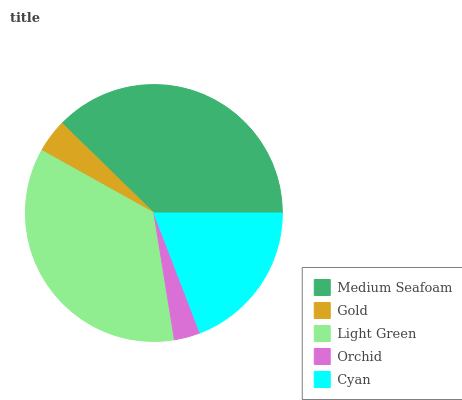Is Orchid the minimum?
Answer yes or no. Yes. Is Medium Seafoam the maximum?
Answer yes or no. Yes. Is Gold the minimum?
Answer yes or no. No. Is Gold the maximum?
Answer yes or no. No. Is Medium Seafoam greater than Gold?
Answer yes or no. Yes. Is Gold less than Medium Seafoam?
Answer yes or no. Yes. Is Gold greater than Medium Seafoam?
Answer yes or no. No. Is Medium Seafoam less than Gold?
Answer yes or no. No. Is Cyan the high median?
Answer yes or no. Yes. Is Cyan the low median?
Answer yes or no. Yes. Is Medium Seafoam the high median?
Answer yes or no. No. Is Medium Seafoam the low median?
Answer yes or no. No. 